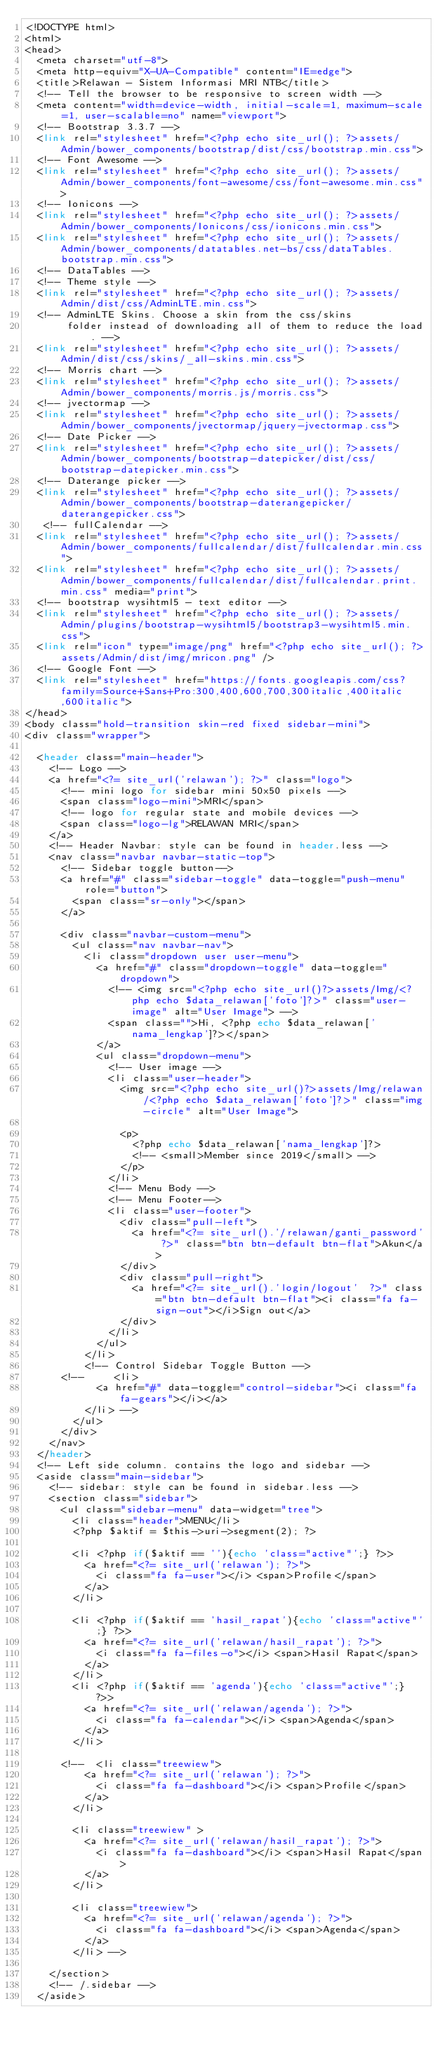Convert code to text. <code><loc_0><loc_0><loc_500><loc_500><_PHP_><!DOCTYPE html>
<html>
<head>
  <meta charset="utf-8">
  <meta http-equiv="X-UA-Compatible" content="IE=edge">
  <title>Relawan - Sistem Informasi MRI NTB</title>
  <!-- Tell the browser to be responsive to screen width -->
  <meta content="width=device-width, initial-scale=1, maximum-scale=1, user-scalable=no" name="viewport">
  <!-- Bootstrap 3.3.7 -->
  <link rel="stylesheet" href="<?php echo site_url(); ?>assets/Admin/bower_components/bootstrap/dist/css/bootstrap.min.css">
  <!-- Font Awesome -->
  <link rel="stylesheet" href="<?php echo site_url(); ?>assets/Admin/bower_components/font-awesome/css/font-awesome.min.css">
  <!-- Ionicons -->
  <link rel="stylesheet" href="<?php echo site_url(); ?>assets/Admin/bower_components/Ionicons/css/ionicons.min.css">
  <link rel="stylesheet" href="<?php echo site_url(); ?>assets/Admin/bower_components/datatables.net-bs/css/dataTables.bootstrap.min.css">
  <!-- DataTables -->
  <!-- Theme style -->
  <link rel="stylesheet" href="<?php echo site_url(); ?>assets/Admin/dist/css/AdminLTE.min.css">
  <!-- AdminLTE Skins. Choose a skin from the css/skins
       folder instead of downloading all of them to reduce the load. -->
  <link rel="stylesheet" href="<?php echo site_url(); ?>assets/Admin/dist/css/skins/_all-skins.min.css">
  <!-- Morris chart -->
  <link rel="stylesheet" href="<?php echo site_url(); ?>assets/Admin/bower_components/morris.js/morris.css">
  <!-- jvectormap -->
  <link rel="stylesheet" href="<?php echo site_url(); ?>assets/Admin/bower_components/jvectormap/jquery-jvectormap.css">
  <!-- Date Picker -->
  <link rel="stylesheet" href="<?php echo site_url(); ?>assets/Admin/bower_components/bootstrap-datepicker/dist/css/bootstrap-datepicker.min.css">
  <!-- Daterange picker -->
  <link rel="stylesheet" href="<?php echo site_url(); ?>assets/Admin/bower_components/bootstrap-daterangepicker/daterangepicker.css">
   <!-- fullCalendar -->
  <link rel="stylesheet" href="<?php echo site_url(); ?>assets/Admin/bower_components/fullcalendar/dist/fullcalendar.min.css">
  <link rel="stylesheet" href="<?php echo site_url(); ?>assets/Admin/bower_components/fullcalendar/dist/fullcalendar.print.min.css" media="print">
  <!-- bootstrap wysihtml5 - text editor -->
  <link rel="stylesheet" href="<?php echo site_url(); ?>assets/Admin/plugins/bootstrap-wysihtml5/bootstrap3-wysihtml5.min.css">
  <link rel="icon" type="image/png" href="<?php echo site_url(); ?>assets/Admin/dist/img/mricon.png" />
  <!-- Google Font -->
  <link rel="stylesheet" href="https://fonts.googleapis.com/css?family=Source+Sans+Pro:300,400,600,700,300italic,400italic,600italic">
</head>
<body class="hold-transition skin-red fixed sidebar-mini">
<div class="wrapper">

  <header class="main-header">
    <!-- Logo -->
    <a href="<?= site_url('relawan'); ?>" class="logo">
      <!-- mini logo for sidebar mini 50x50 pixels -->
      <span class="logo-mini">MRI</span>
      <!-- logo for regular state and mobile devices -->
      <span class="logo-lg">RELAWAN MRI</span>
    </a>
    <!-- Header Navbar: style can be found in header.less -->
    <nav class="navbar navbar-static-top">
      <!-- Sidebar toggle button-->
      <a href="#" class="sidebar-toggle" data-toggle="push-menu" role="button">
        <span class="sr-only"></span>
      </a>

      <div class="navbar-custom-menu">
        <ul class="nav navbar-nav">
          <li class="dropdown user user-menu">
            <a href="#" class="dropdown-toggle" data-toggle="dropdown">
              <!-- <img src="<?php echo site_url()?>assets/Img/<?php echo $data_relawan['foto']?>" class="user-image" alt="User Image"> -->
              <span class="">Hi, <?php echo $data_relawan['nama_lengkap']?></span>
            </a>
            <ul class="dropdown-menu">
              <!-- User image -->
              <li class="user-header">
                <img src="<?php echo site_url()?>assets/Img/relawan/<?php echo $data_relawan['foto']?>" class="img-circle" alt="User Image">

                <p>
                  <?php echo $data_relawan['nama_lengkap']?>
                  <!-- <small>Member since 2019</small> -->
                </p>
              </li>
              <!-- Menu Body -->
              <!-- Menu Footer-->
              <li class="user-footer">
                <div class="pull-left">
                  <a href="<?= site_url().'/relawan/ganti_password' ?>" class="btn btn-default btn-flat">Akun</a>
                </div>
                <div class="pull-right">
                  <a href="<?= site_url().'login/logout'  ?>" class="btn btn-default btn-flat"><i class="fa fa-sign-out"></i>Sign out</a>
                </div>
              </li>
            </ul>
          </li>
          <!-- Control Sidebar Toggle Button -->
      <!--     <li>
            <a href="#" data-toggle="control-sidebar"><i class="fa fa-gears"></i></a>
          </li> -->
        </ul>
      </div>
    </nav>
  </header>
  <!-- Left side column. contains the logo and sidebar -->
  <aside class="main-sidebar">
    <!-- sidebar: style can be found in sidebar.less -->
    <section class="sidebar">
      <ul class="sidebar-menu" data-widget="tree">
        <li class="header">MENU</li>
        <?php $aktif = $this->uri->segment(2); ?>

        <li <?php if($aktif == ''){echo 'class="active"';} ?>>
          <a href="<?= site_url('relawan'); ?>">
            <i class="fa fa-user"></i> <span>Profile</span>
          </a>
        </li>

        <li <?php if($aktif == 'hasil_rapat'){echo 'class="active"';} ?>>
          <a href="<?= site_url('relawan/hasil_rapat'); ?>">
            <i class="fa fa-files-o"></i> <span>Hasil Rapat</span>
          </a>
        </li>
        <li <?php if($aktif == 'agenda'){echo 'class="active"';} ?>>
          <a href="<?= site_url('relawan/agenda'); ?>">
            <i class="fa fa-calendar"></i> <span>Agenda</span>
          </a>
        </li>

      <!--  <li class="treewiew">
          <a href="<?= site_url('relawan'); ?>">
            <i class="fa fa-dashboard"></i> <span>Profile</span>
          </a>
        </li>

        <li class="treewiew" >
          <a href="<?= site_url('relawan/hasil_rapat'); ?>">
            <i class="fa fa-dashboard"></i> <span>Hasil Rapat</span>
          </a>
        </li>

        <li class="treewiew">
          <a href="<?= site_url('relawan/agenda'); ?>">
            <i class="fa fa-dashboard"></i> <span>Agenda</span>
          </a>
        </li> -->
        
    </section>
    <!-- /.sidebar -->
  </aside>
</code> 